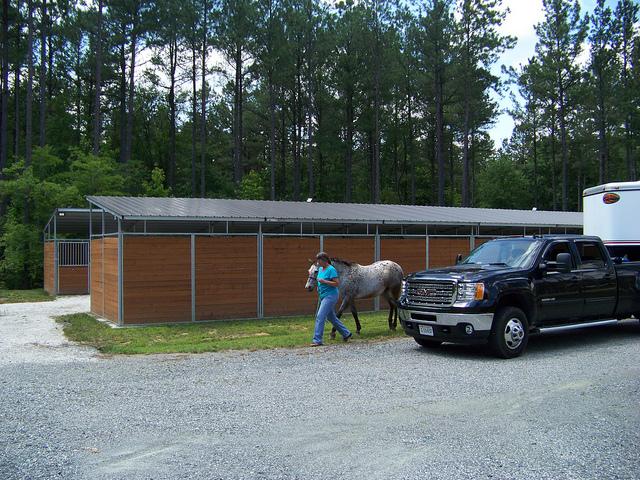What animal is being pulled?
Give a very brief answer. Horse. How many animals?
Write a very short answer. 1. What type of stables are in the background?
Keep it brief. Horse. 